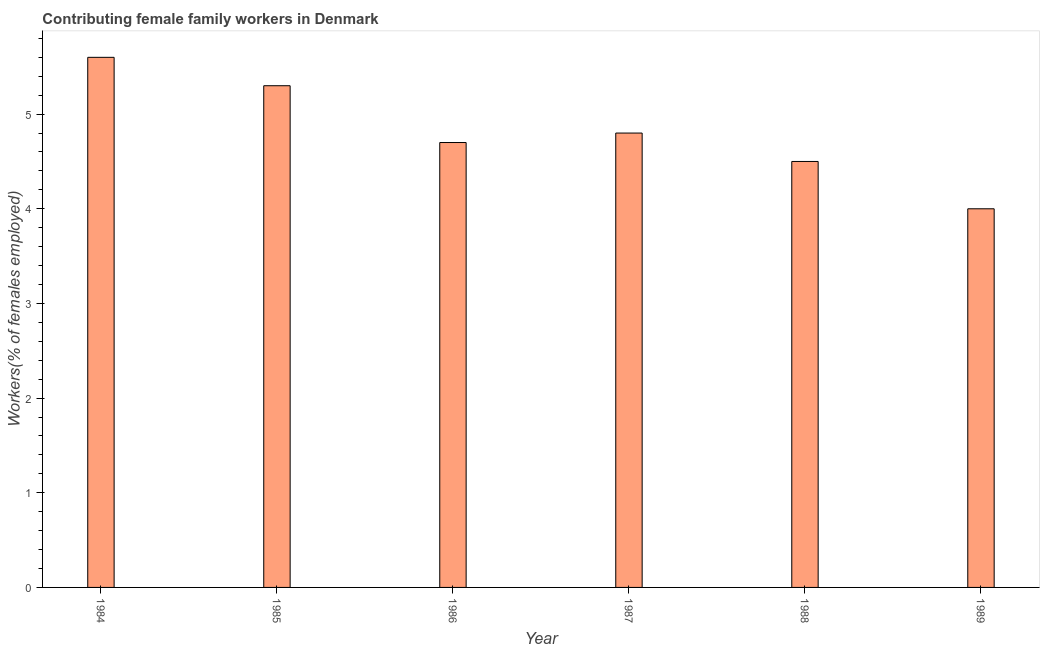Does the graph contain any zero values?
Keep it short and to the point. No. What is the title of the graph?
Give a very brief answer. Contributing female family workers in Denmark. What is the label or title of the Y-axis?
Offer a terse response. Workers(% of females employed). What is the contributing female family workers in 1988?
Your answer should be compact. 4.5. Across all years, what is the maximum contributing female family workers?
Your answer should be compact. 5.6. In which year was the contributing female family workers maximum?
Give a very brief answer. 1984. What is the sum of the contributing female family workers?
Provide a succinct answer. 28.9. What is the average contributing female family workers per year?
Provide a succinct answer. 4.82. What is the median contributing female family workers?
Your answer should be very brief. 4.75. Do a majority of the years between 1985 and 1988 (inclusive) have contributing female family workers greater than 1 %?
Offer a terse response. Yes. What is the ratio of the contributing female family workers in 1984 to that in 1988?
Offer a terse response. 1.24. Is the contributing female family workers in 1987 less than that in 1989?
Keep it short and to the point. No. Is the difference between the contributing female family workers in 1986 and 1989 greater than the difference between any two years?
Offer a very short reply. No. What is the difference between the highest and the lowest contributing female family workers?
Your response must be concise. 1.6. How many bars are there?
Provide a short and direct response. 6. Are the values on the major ticks of Y-axis written in scientific E-notation?
Your response must be concise. No. What is the Workers(% of females employed) of 1984?
Your response must be concise. 5.6. What is the Workers(% of females employed) of 1985?
Provide a succinct answer. 5.3. What is the Workers(% of females employed) of 1986?
Keep it short and to the point. 4.7. What is the Workers(% of females employed) of 1987?
Ensure brevity in your answer.  4.8. What is the Workers(% of females employed) of 1988?
Ensure brevity in your answer.  4.5. What is the Workers(% of females employed) of 1989?
Offer a terse response. 4. What is the difference between the Workers(% of females employed) in 1984 and 1986?
Ensure brevity in your answer.  0.9. What is the difference between the Workers(% of females employed) in 1984 and 1987?
Your answer should be compact. 0.8. What is the difference between the Workers(% of females employed) in 1984 and 1988?
Your answer should be very brief. 1.1. What is the difference between the Workers(% of females employed) in 1985 and 1988?
Provide a succinct answer. 0.8. What is the difference between the Workers(% of females employed) in 1986 and 1987?
Provide a short and direct response. -0.1. What is the difference between the Workers(% of females employed) in 1986 and 1988?
Your answer should be compact. 0.2. What is the difference between the Workers(% of females employed) in 1986 and 1989?
Your answer should be compact. 0.7. What is the difference between the Workers(% of females employed) in 1987 and 1988?
Offer a very short reply. 0.3. What is the difference between the Workers(% of females employed) in 1987 and 1989?
Offer a very short reply. 0.8. What is the ratio of the Workers(% of females employed) in 1984 to that in 1985?
Provide a succinct answer. 1.06. What is the ratio of the Workers(% of females employed) in 1984 to that in 1986?
Offer a very short reply. 1.19. What is the ratio of the Workers(% of females employed) in 1984 to that in 1987?
Ensure brevity in your answer.  1.17. What is the ratio of the Workers(% of females employed) in 1984 to that in 1988?
Provide a succinct answer. 1.24. What is the ratio of the Workers(% of females employed) in 1985 to that in 1986?
Offer a terse response. 1.13. What is the ratio of the Workers(% of females employed) in 1985 to that in 1987?
Your answer should be compact. 1.1. What is the ratio of the Workers(% of females employed) in 1985 to that in 1988?
Ensure brevity in your answer.  1.18. What is the ratio of the Workers(% of females employed) in 1985 to that in 1989?
Your answer should be compact. 1.32. What is the ratio of the Workers(% of females employed) in 1986 to that in 1988?
Ensure brevity in your answer.  1.04. What is the ratio of the Workers(% of females employed) in 1986 to that in 1989?
Make the answer very short. 1.18. What is the ratio of the Workers(% of females employed) in 1987 to that in 1988?
Ensure brevity in your answer.  1.07. 